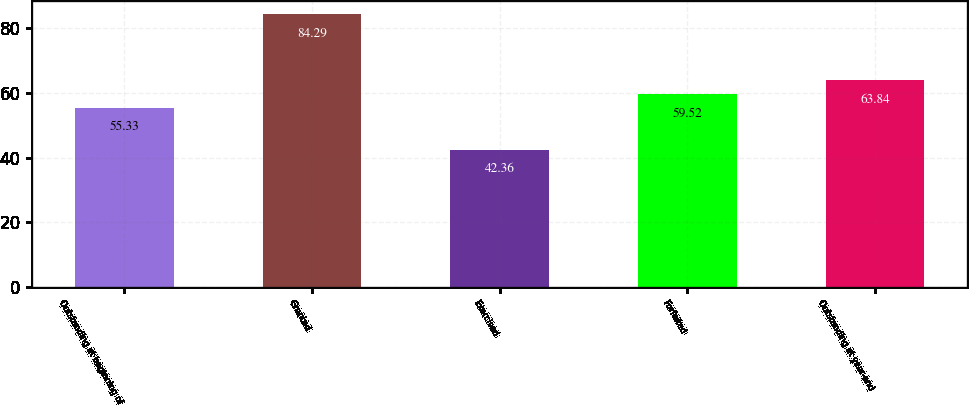<chart> <loc_0><loc_0><loc_500><loc_500><bar_chart><fcel>Outstanding at beginning of<fcel>Granted<fcel>Exercised<fcel>Forfeited<fcel>Outstanding at year-end<nl><fcel>55.33<fcel>84.29<fcel>42.36<fcel>59.52<fcel>63.84<nl></chart> 